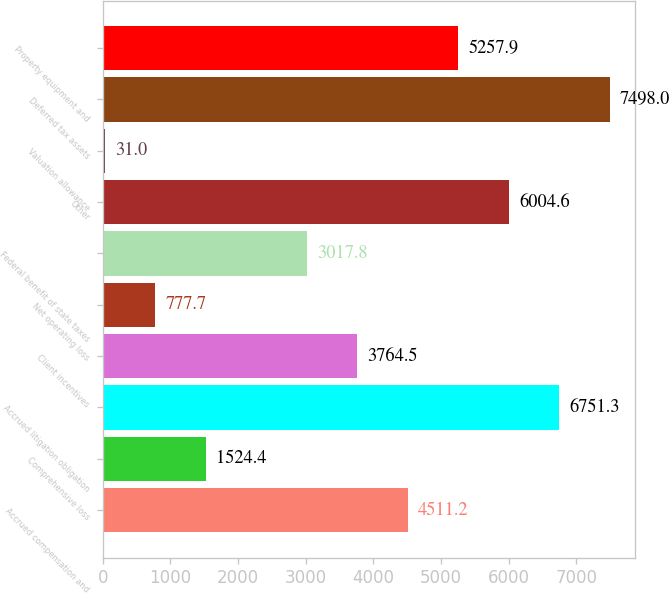Convert chart to OTSL. <chart><loc_0><loc_0><loc_500><loc_500><bar_chart><fcel>Accrued compensation and<fcel>Comprehensive loss<fcel>Accrued litigation obligation<fcel>Client incentives<fcel>Net operating loss<fcel>Federal benefit of state taxes<fcel>Other<fcel>Valuation allowance<fcel>Deferred tax assets<fcel>Property equipment and<nl><fcel>4511.2<fcel>1524.4<fcel>6751.3<fcel>3764.5<fcel>777.7<fcel>3017.8<fcel>6004.6<fcel>31<fcel>7498<fcel>5257.9<nl></chart> 